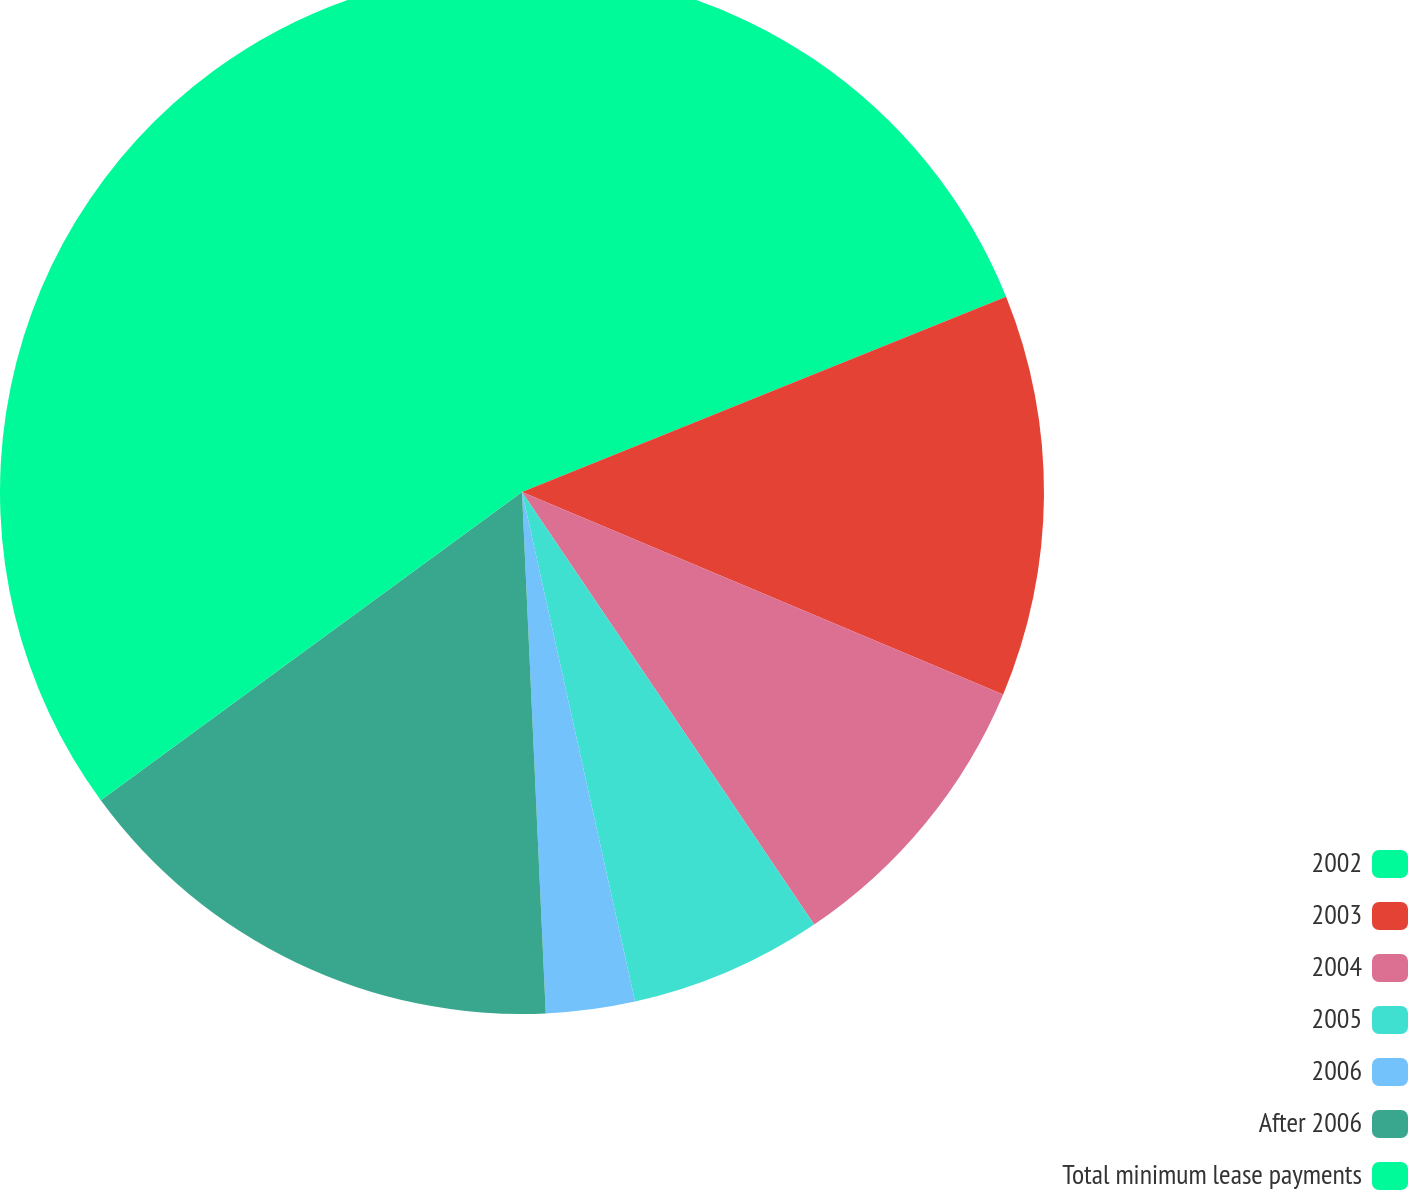Convert chart to OTSL. <chart><loc_0><loc_0><loc_500><loc_500><pie_chart><fcel>2002<fcel>2003<fcel>2004<fcel>2005<fcel>2006<fcel>After 2006<fcel>Total minimum lease payments<nl><fcel>18.9%<fcel>12.44%<fcel>9.21%<fcel>5.98%<fcel>2.75%<fcel>15.67%<fcel>35.06%<nl></chart> 